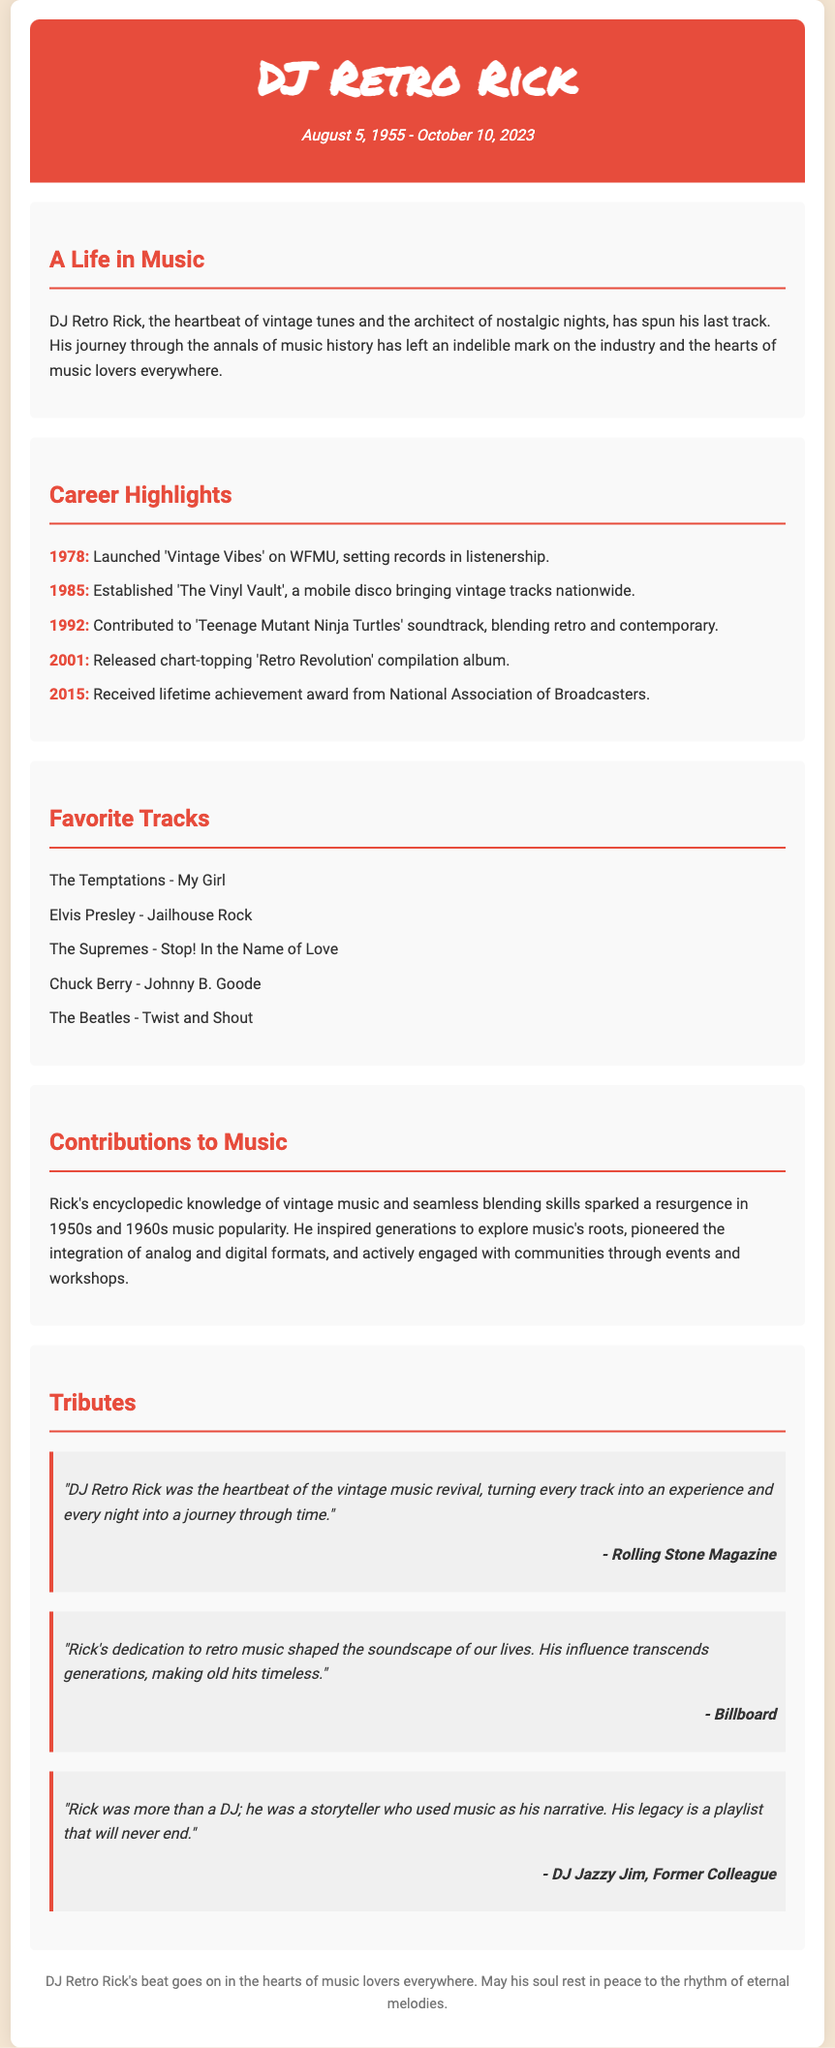What was DJ Retro Rick's full name? The document mentions the full name as DJ Retro Rick.
Answer: DJ Retro Rick When was DJ Retro Rick born? The birth date provided in the document is August 5, 1955.
Answer: August 5, 1955 What year did DJ Retro Rick release the 'Retro Revolution' compilation album? The document states that this album was released in 2001.
Answer: 2001 Which magazine described DJ Retro Rick as the heartbeat of the vintage music revival? The quote in the tributes section attributes this description to Rolling Stone Magazine.
Answer: Rolling Stone Magazine How many significant career highlights are listed in the document? There are a total of five career highlights mentioned.
Answer: 5 What contribution did DJ Retro Rick make to music popularization? He sparked a resurgence in 1950s and 1960s music popularity.
Answer: 1950s and 1960s music popularity What event did DJ Retro Rick receive a lifetime achievement award? The document notes that he received this award in 2015 from the National Association of Broadcasters.
Answer: 2015 Which track by Elvis Presley is listed as one of DJ Retro Rick's favorite tracks? The favorite track mentioned is "Jailhouse Rock."
Answer: Jailhouse Rock Who described DJ Retro Rick as a storyteller who used music as his narrative? This quote is attributed to DJ Jazzy Jim, a former colleague.
Answer: DJ Jazzy Jim 